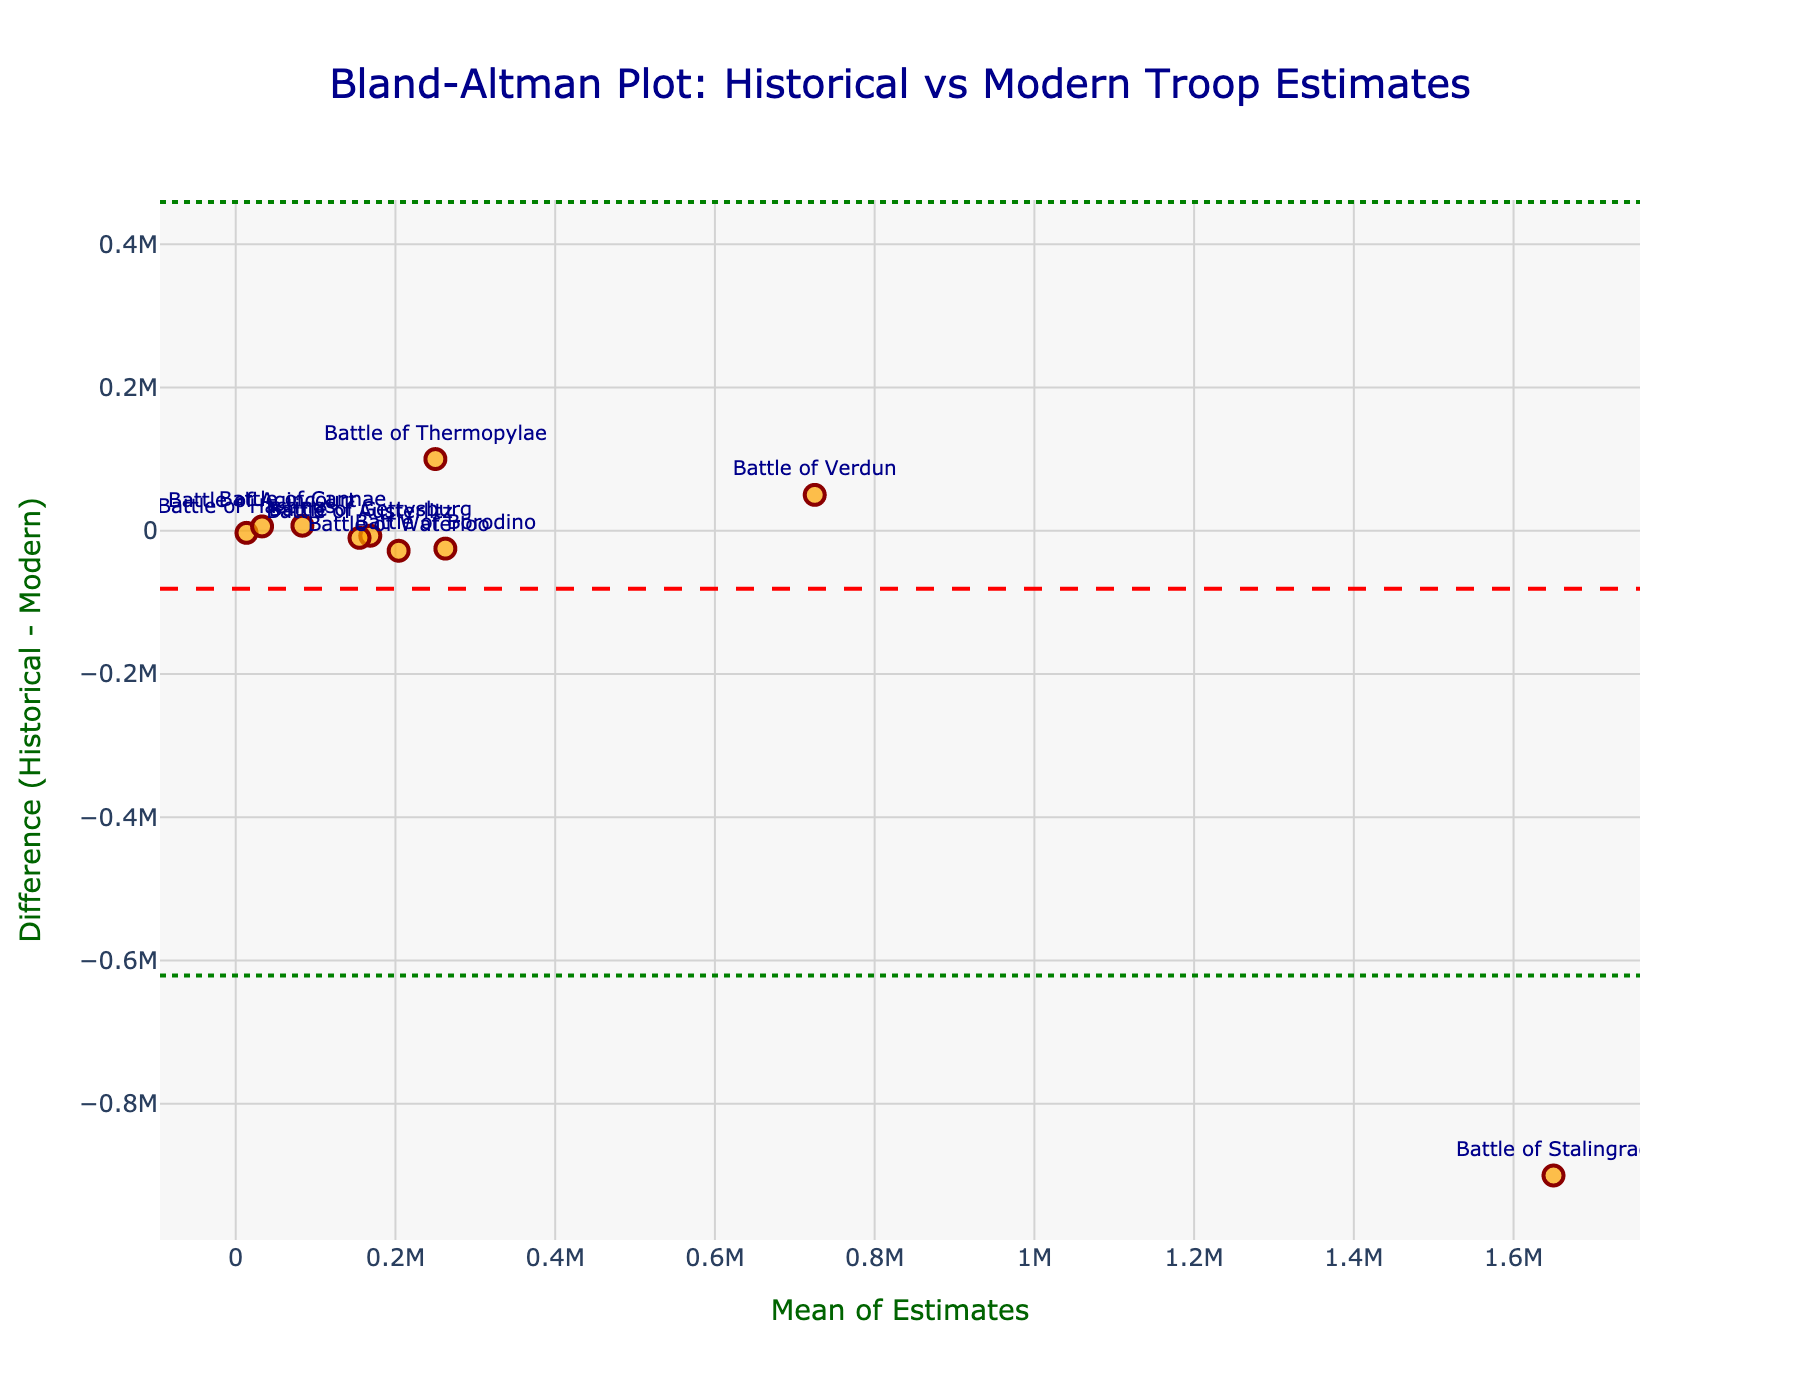What's the title of the plot? The title of the plot is usually found at the top of the figure and can be read directly. In this case, it would be the large prominent text that summarizes the content.
Answer: Bland-Altman Plot: Historical vs Modern Troop Estimates What is the mean difference between historical and modern estimates? The mean difference is directly indicated on the plot with a red dashed line. This line marks the average of all the differences between the historical and modern estimates.
Answer: ~ -82000 Which battle has the largest positive difference between historical and modern troop estimates? The largest positive difference means the historical estimate is much higher than the modern estimate. This can be identified by finding the highest point on the y-axis above the zero line.
Answer: Battle of Thermopylae What is the range of mean estimates shown on the x-axis? To find the range, identify the minimum and maximum values on the x-axis (mean estimates) and calculate the difference between these two points. The range indicates the spread of data points from left to right.
Answer: 13500 to 1650000 How many battles have a negative difference, where historical estimates are lower than modern estimates? Count the number of data points that fall below the zero line on the y-axis, indicating instances where historical estimates are lower than modern estimates.
Answer: 5 What are the limits of agreement for this plot? The limits of agreement are shown as two green dotted lines, indicating the range within which 95% of the differences between estimates fall. These are labeled and can be read directly from the plot.
Answer: ~ -826698 and 662698 How does the Battle of Stalingrad compare in terms of difference versus mean estimate? Locate the point labeled "Battle of Stalingrad" and assess its position in both mean estimate (x-axis) and difference (y-axis) to describe how it compares to other battles.
Answer: Negative difference and high mean estimate Which battle has the smallest mean estimate? Identify the battle closest to the leftmost part of the x-axis, as this indicates the smallest mean estimate.
Answer: Battle of Hastings Is there any battle with a very close estimate by historical and modern records? Find the data point closest to the zero line on the y-axis, which would signify nearly equal historical and modern estimates.
Answer: Battle of Agincourt What does the placement of the Battle of Verdun suggest about the accuracy of historical estimates? Analyze the position of "Battle of Verdun" relative to the zero line. If it is close to the zero line, the historical and modern estimates are similar, indicating higher historical accuracy. If it is far above or below, it suggests a significant difference.
Answer: Historical estimate is higher than the modern estimate 